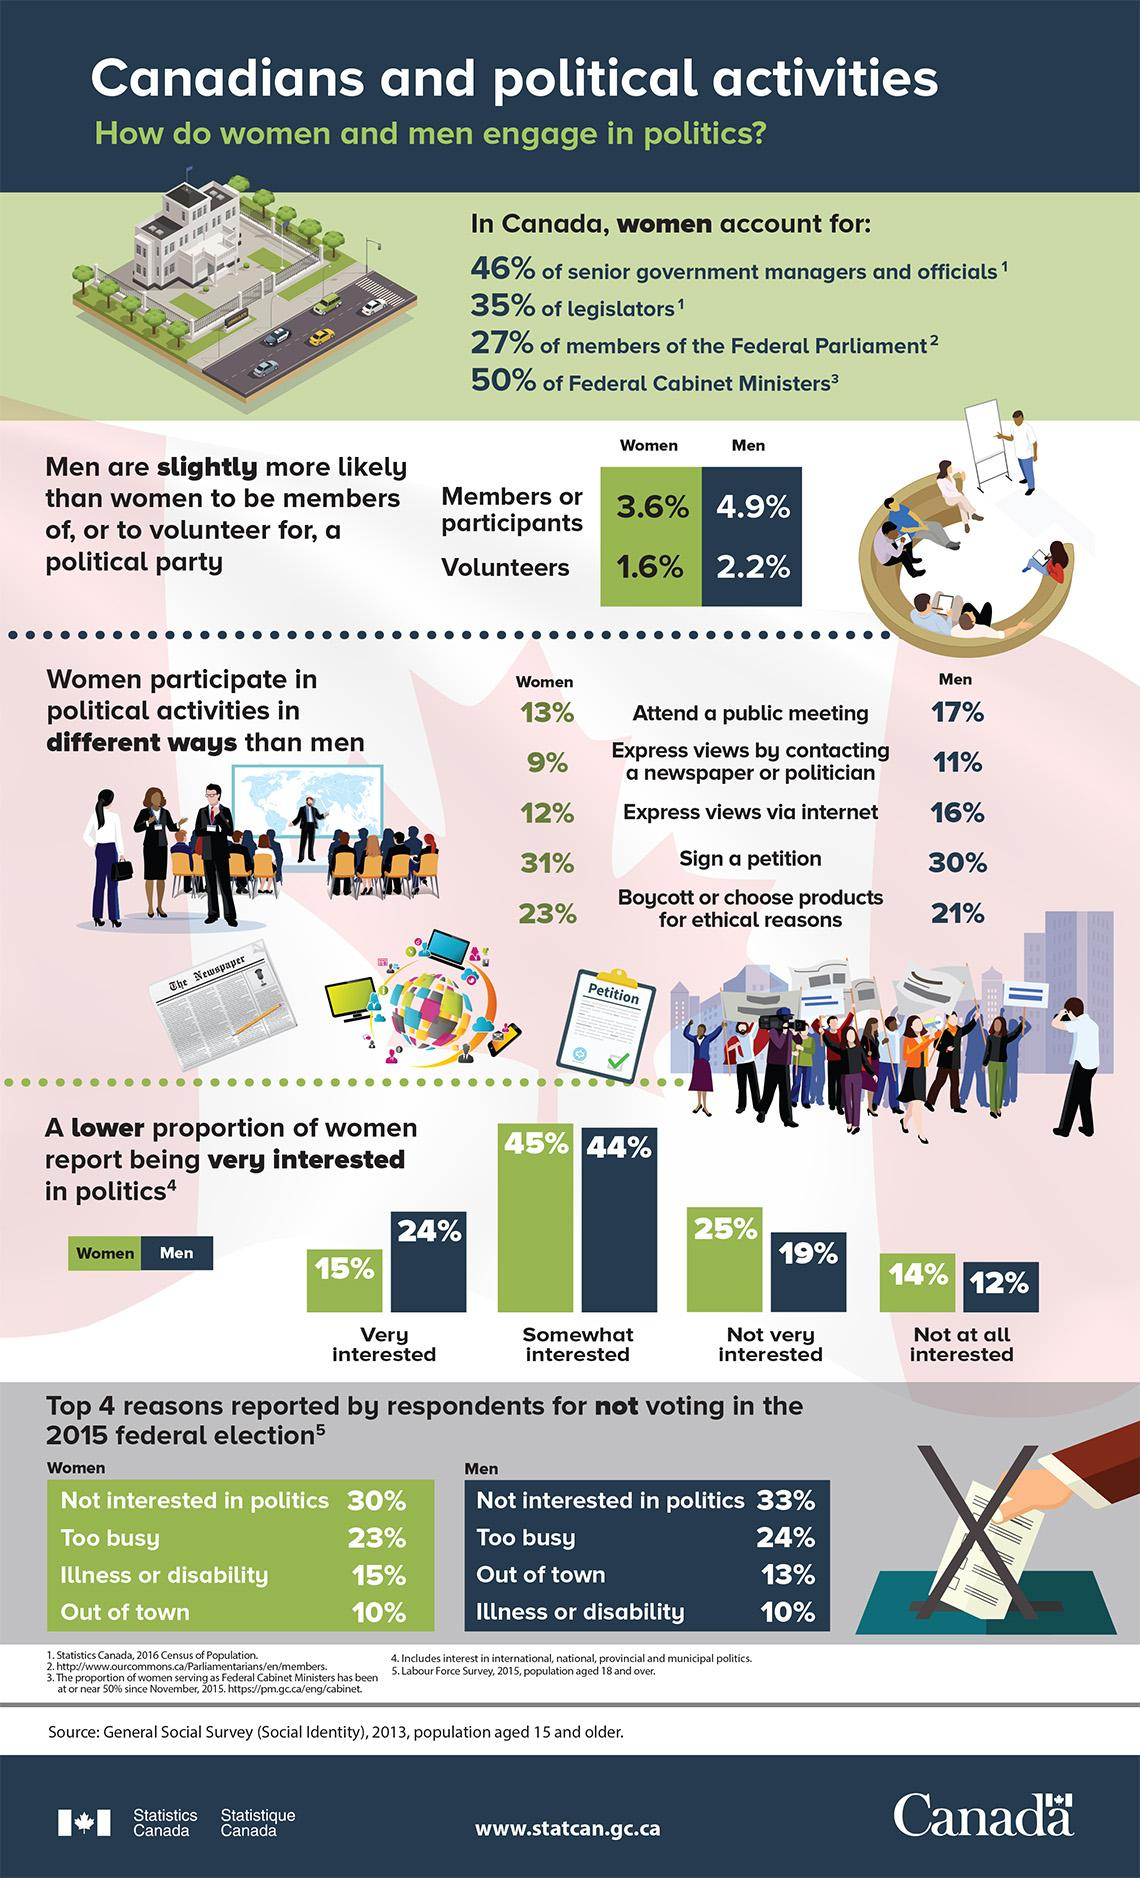Give some essential details in this illustration. According to the 2016 Census of Population, 35% of legislators in Canada are women. In 2013, the General Social Survey in Canada found that only 4.9% of the male population were members or participants of a political party. According to the survey, 44% of Canadian men are somewhat interested in politics. According to the survey, only 1.6% of Canadian women volunteer for a political party. According to the General Social Survey in 2013, 15% of Canadian women expressed a high level of interest in politics. 